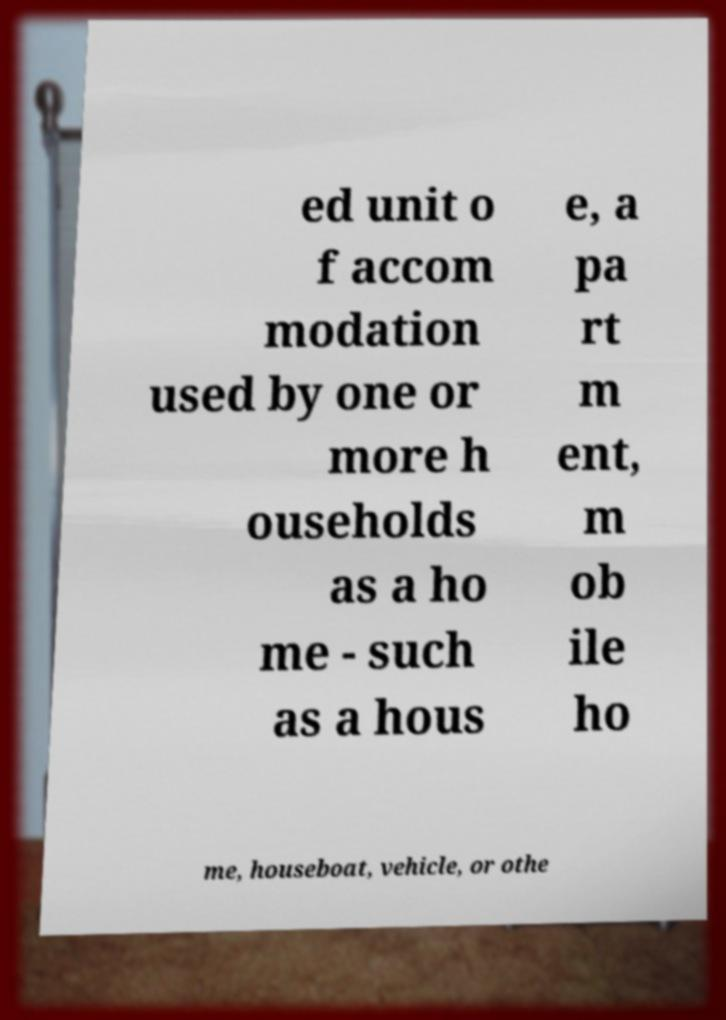I need the written content from this picture converted into text. Can you do that? ed unit o f accom modation used by one or more h ouseholds as a ho me - such as a hous e, a pa rt m ent, m ob ile ho me, houseboat, vehicle, or othe 